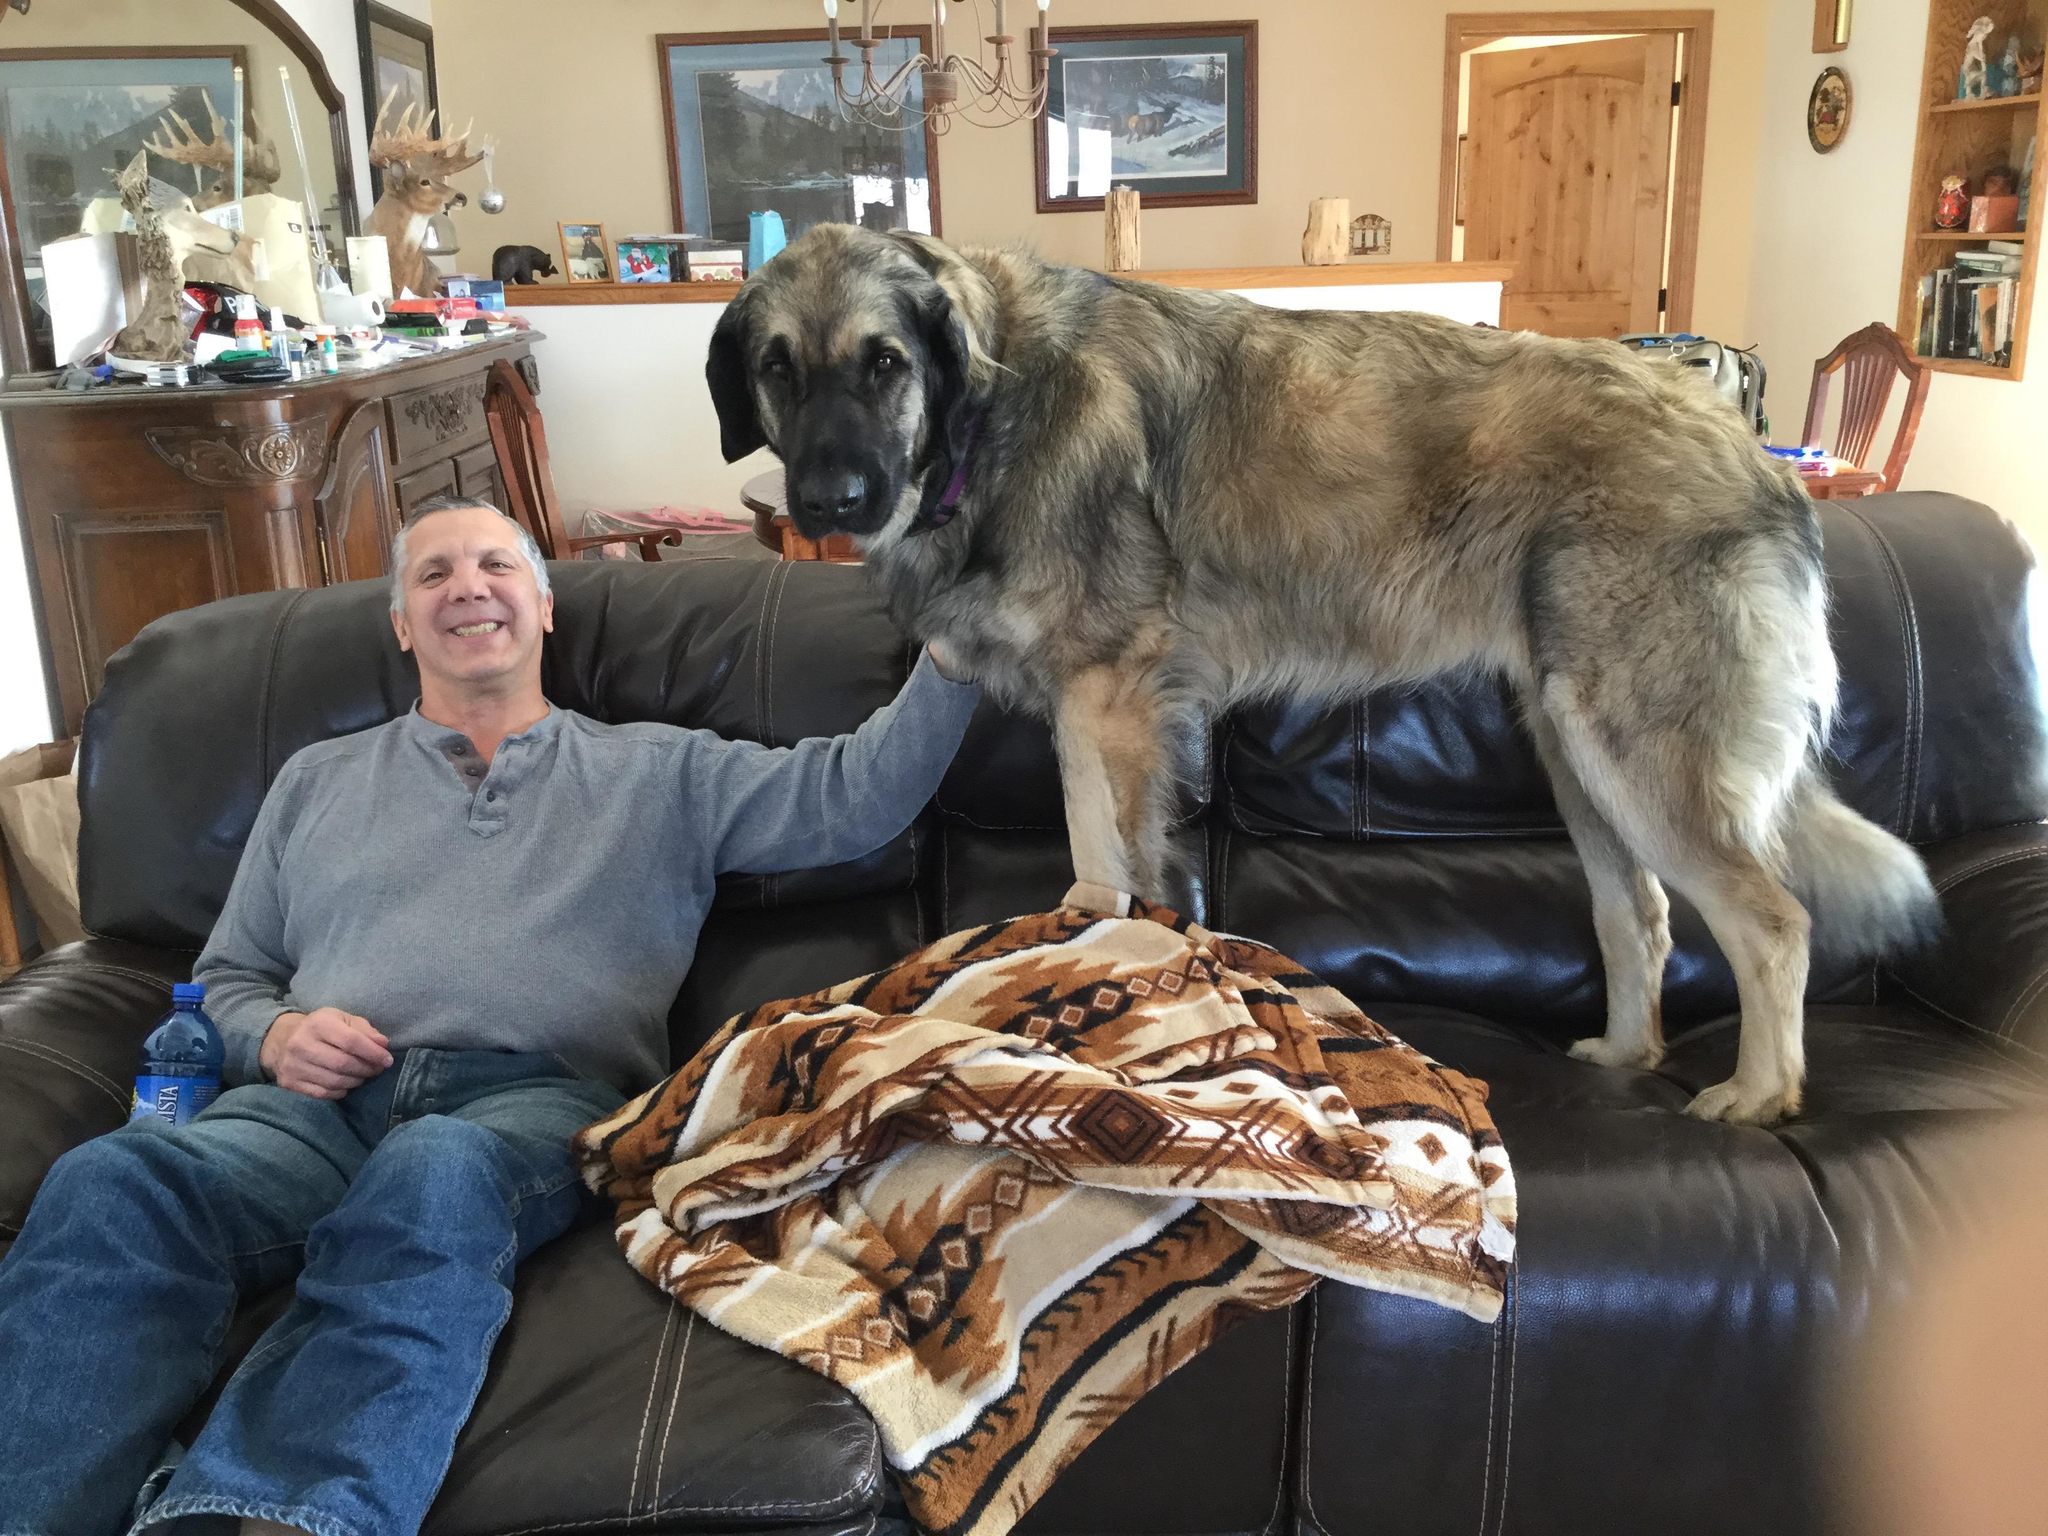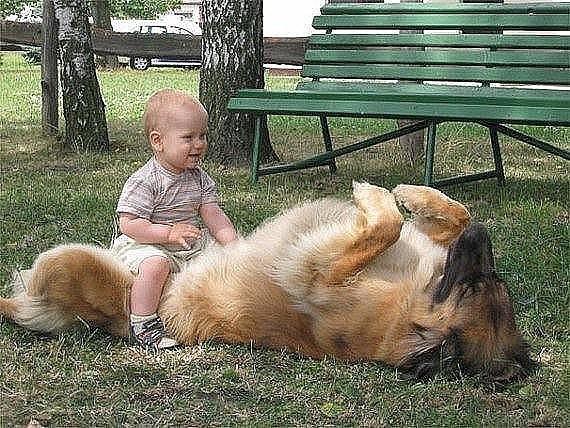The first image is the image on the left, the second image is the image on the right. Given the left and right images, does the statement "Right image shows one furry dog in an outdoor area enclosed by wire." hold true? Answer yes or no. No. The first image is the image on the left, the second image is the image on the right. Considering the images on both sides, is "Both dogs are outside on the grass." valid? Answer yes or no. No. 